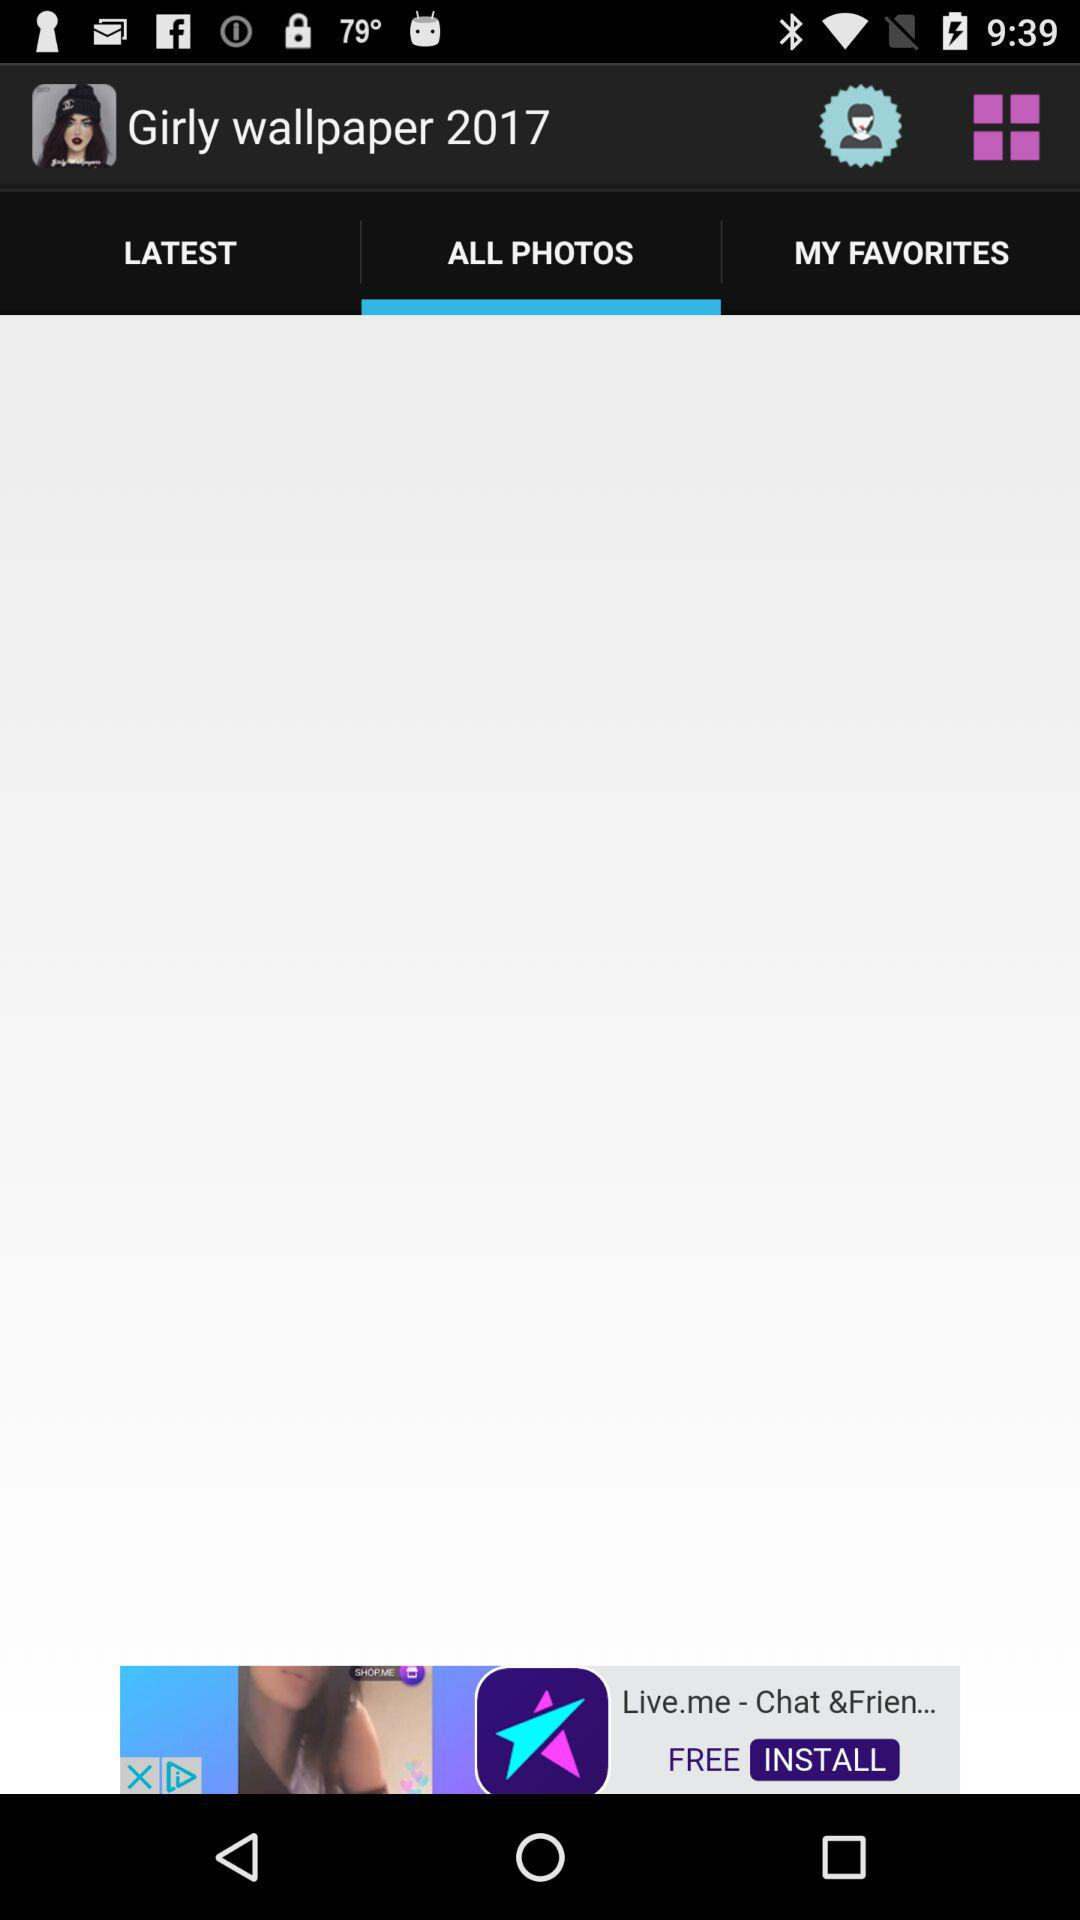Which tab has been selected? The selected tab is All Photos. 